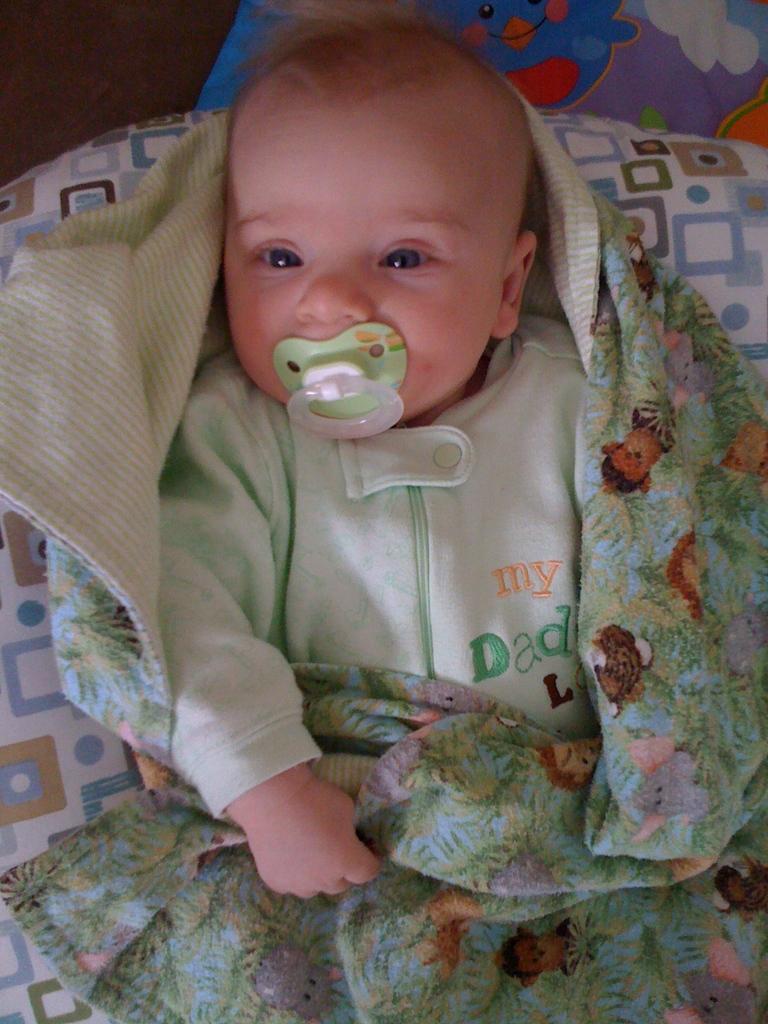Could you give a brief overview of what you see in this image? In this image I can see a baby lying in a bed with a bed sheet with a nipple or soother in his mouth. 